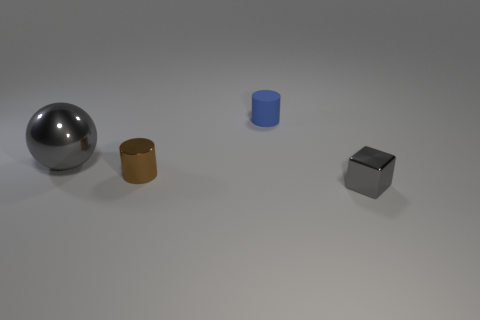Does the rubber thing have the same shape as the gray thing that is in front of the big gray shiny sphere?
Provide a succinct answer. No. How many objects are objects that are to the right of the metal ball or gray metal cubes?
Keep it short and to the point. 3. Is there any other thing that has the same material as the blue cylinder?
Provide a short and direct response. No. How many metal things are both left of the tiny blue thing and in front of the large object?
Keep it short and to the point. 1. How many things are gray metallic blocks that are on the right side of the tiny rubber object or gray metal things right of the large metal object?
Make the answer very short. 1. How many other objects are the same shape as the blue thing?
Your answer should be very brief. 1. Does the shiny thing that is behind the brown shiny thing have the same color as the tiny metallic cylinder?
Offer a very short reply. No. What number of other things are there of the same size as the gray metal cube?
Offer a very short reply. 2. Does the large gray ball have the same material as the small blue cylinder?
Your response must be concise. No. There is a tiny shiny object on the left side of the thing that is right of the blue cylinder; what color is it?
Provide a short and direct response. Brown. 